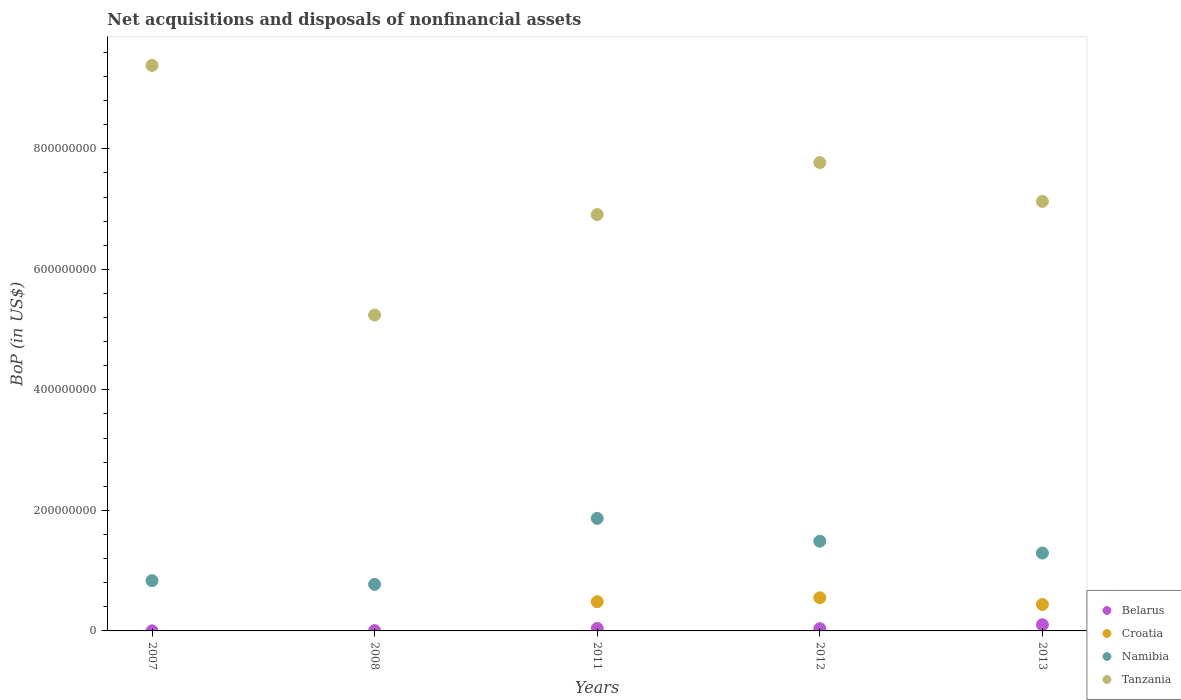How many different coloured dotlines are there?
Offer a very short reply. 4. Is the number of dotlines equal to the number of legend labels?
Offer a terse response. No. What is the Balance of Payments in Tanzania in 2007?
Ensure brevity in your answer.  9.39e+08. Across all years, what is the maximum Balance of Payments in Tanzania?
Offer a very short reply. 9.39e+08. What is the total Balance of Payments in Namibia in the graph?
Offer a terse response. 6.25e+08. What is the difference between the Balance of Payments in Croatia in 2011 and that in 2012?
Make the answer very short. -6.49e+06. What is the difference between the Balance of Payments in Namibia in 2013 and the Balance of Payments in Croatia in 2007?
Offer a terse response. 1.29e+08. What is the average Balance of Payments in Belarus per year?
Provide a short and direct response. 3.74e+06. In the year 2007, what is the difference between the Balance of Payments in Tanzania and Balance of Payments in Belarus?
Give a very brief answer. 9.38e+08. What is the ratio of the Balance of Payments in Belarus in 2008 to that in 2012?
Offer a terse response. 0.14. Is the Balance of Payments in Namibia in 2008 less than that in 2013?
Your response must be concise. Yes. What is the difference between the highest and the second highest Balance of Payments in Belarus?
Provide a short and direct response. 6.20e+06. What is the difference between the highest and the lowest Balance of Payments in Croatia?
Your answer should be very brief. 5.50e+07. In how many years, is the Balance of Payments in Namibia greater than the average Balance of Payments in Namibia taken over all years?
Your answer should be compact. 3. Is the Balance of Payments in Tanzania strictly greater than the Balance of Payments in Croatia over the years?
Make the answer very short. Yes. Is the Balance of Payments in Tanzania strictly less than the Balance of Payments in Namibia over the years?
Keep it short and to the point. No. How many years are there in the graph?
Provide a succinct answer. 5. What is the difference between two consecutive major ticks on the Y-axis?
Provide a succinct answer. 2.00e+08. Are the values on the major ticks of Y-axis written in scientific E-notation?
Provide a succinct answer. No. Does the graph contain any zero values?
Provide a succinct answer. Yes. Where does the legend appear in the graph?
Your answer should be compact. Bottom right. How many legend labels are there?
Give a very brief answer. 4. What is the title of the graph?
Ensure brevity in your answer.  Net acquisitions and disposals of nonfinancial assets. Does "San Marino" appear as one of the legend labels in the graph?
Your answer should be compact. No. What is the label or title of the X-axis?
Keep it short and to the point. Years. What is the label or title of the Y-axis?
Offer a very short reply. BoP (in US$). What is the BoP (in US$) in Belarus in 2007?
Provide a short and direct response. 1.00e+05. What is the BoP (in US$) of Namibia in 2007?
Give a very brief answer. 8.34e+07. What is the BoP (in US$) of Tanzania in 2007?
Offer a terse response. 9.39e+08. What is the BoP (in US$) of Croatia in 2008?
Provide a succinct answer. 0. What is the BoP (in US$) in Namibia in 2008?
Give a very brief answer. 7.72e+07. What is the BoP (in US$) in Tanzania in 2008?
Provide a succinct answer. 5.24e+08. What is the BoP (in US$) in Belarus in 2011?
Make the answer very short. 4.10e+06. What is the BoP (in US$) of Croatia in 2011?
Offer a very short reply. 4.85e+07. What is the BoP (in US$) of Namibia in 2011?
Offer a very short reply. 1.87e+08. What is the BoP (in US$) of Tanzania in 2011?
Your answer should be very brief. 6.91e+08. What is the BoP (in US$) in Belarus in 2012?
Make the answer very short. 3.70e+06. What is the BoP (in US$) in Croatia in 2012?
Provide a short and direct response. 5.50e+07. What is the BoP (in US$) of Namibia in 2012?
Offer a very short reply. 1.49e+08. What is the BoP (in US$) of Tanzania in 2012?
Give a very brief answer. 7.77e+08. What is the BoP (in US$) in Belarus in 2013?
Offer a very short reply. 1.03e+07. What is the BoP (in US$) of Croatia in 2013?
Offer a terse response. 4.39e+07. What is the BoP (in US$) in Namibia in 2013?
Ensure brevity in your answer.  1.29e+08. What is the BoP (in US$) in Tanzania in 2013?
Make the answer very short. 7.13e+08. Across all years, what is the maximum BoP (in US$) of Belarus?
Offer a very short reply. 1.03e+07. Across all years, what is the maximum BoP (in US$) in Croatia?
Offer a very short reply. 5.50e+07. Across all years, what is the maximum BoP (in US$) in Namibia?
Your answer should be compact. 1.87e+08. Across all years, what is the maximum BoP (in US$) in Tanzania?
Give a very brief answer. 9.39e+08. Across all years, what is the minimum BoP (in US$) of Namibia?
Keep it short and to the point. 7.72e+07. Across all years, what is the minimum BoP (in US$) in Tanzania?
Provide a short and direct response. 5.24e+08. What is the total BoP (in US$) of Belarus in the graph?
Your response must be concise. 1.87e+07. What is the total BoP (in US$) in Croatia in the graph?
Provide a short and direct response. 1.47e+08. What is the total BoP (in US$) in Namibia in the graph?
Your answer should be very brief. 6.25e+08. What is the total BoP (in US$) in Tanzania in the graph?
Give a very brief answer. 3.64e+09. What is the difference between the BoP (in US$) of Belarus in 2007 and that in 2008?
Make the answer very short. -4.00e+05. What is the difference between the BoP (in US$) in Namibia in 2007 and that in 2008?
Provide a succinct answer. 6.20e+06. What is the difference between the BoP (in US$) of Tanzania in 2007 and that in 2008?
Give a very brief answer. 4.14e+08. What is the difference between the BoP (in US$) in Namibia in 2007 and that in 2011?
Give a very brief answer. -1.03e+08. What is the difference between the BoP (in US$) of Tanzania in 2007 and that in 2011?
Provide a succinct answer. 2.48e+08. What is the difference between the BoP (in US$) in Belarus in 2007 and that in 2012?
Keep it short and to the point. -3.60e+06. What is the difference between the BoP (in US$) of Namibia in 2007 and that in 2012?
Ensure brevity in your answer.  -6.54e+07. What is the difference between the BoP (in US$) of Tanzania in 2007 and that in 2012?
Your answer should be compact. 1.61e+08. What is the difference between the BoP (in US$) of Belarus in 2007 and that in 2013?
Provide a succinct answer. -1.02e+07. What is the difference between the BoP (in US$) of Namibia in 2007 and that in 2013?
Your response must be concise. -4.58e+07. What is the difference between the BoP (in US$) of Tanzania in 2007 and that in 2013?
Your response must be concise. 2.26e+08. What is the difference between the BoP (in US$) of Belarus in 2008 and that in 2011?
Make the answer very short. -3.60e+06. What is the difference between the BoP (in US$) of Namibia in 2008 and that in 2011?
Keep it short and to the point. -1.10e+08. What is the difference between the BoP (in US$) in Tanzania in 2008 and that in 2011?
Provide a short and direct response. -1.67e+08. What is the difference between the BoP (in US$) of Belarus in 2008 and that in 2012?
Give a very brief answer. -3.20e+06. What is the difference between the BoP (in US$) of Namibia in 2008 and that in 2012?
Ensure brevity in your answer.  -7.16e+07. What is the difference between the BoP (in US$) in Tanzania in 2008 and that in 2012?
Your answer should be very brief. -2.53e+08. What is the difference between the BoP (in US$) in Belarus in 2008 and that in 2013?
Provide a short and direct response. -9.80e+06. What is the difference between the BoP (in US$) in Namibia in 2008 and that in 2013?
Offer a terse response. -5.20e+07. What is the difference between the BoP (in US$) in Tanzania in 2008 and that in 2013?
Offer a very short reply. -1.89e+08. What is the difference between the BoP (in US$) in Croatia in 2011 and that in 2012?
Your answer should be very brief. -6.49e+06. What is the difference between the BoP (in US$) of Namibia in 2011 and that in 2012?
Your answer should be compact. 3.79e+07. What is the difference between the BoP (in US$) of Tanzania in 2011 and that in 2012?
Your response must be concise. -8.63e+07. What is the difference between the BoP (in US$) of Belarus in 2011 and that in 2013?
Offer a terse response. -6.20e+06. What is the difference between the BoP (in US$) of Croatia in 2011 and that in 2013?
Your answer should be very brief. 4.67e+06. What is the difference between the BoP (in US$) in Namibia in 2011 and that in 2013?
Your response must be concise. 5.76e+07. What is the difference between the BoP (in US$) of Tanzania in 2011 and that in 2013?
Your answer should be compact. -2.19e+07. What is the difference between the BoP (in US$) in Belarus in 2012 and that in 2013?
Provide a succinct answer. -6.60e+06. What is the difference between the BoP (in US$) in Croatia in 2012 and that in 2013?
Keep it short and to the point. 1.12e+07. What is the difference between the BoP (in US$) of Namibia in 2012 and that in 2013?
Your response must be concise. 1.96e+07. What is the difference between the BoP (in US$) in Tanzania in 2012 and that in 2013?
Your response must be concise. 6.44e+07. What is the difference between the BoP (in US$) in Belarus in 2007 and the BoP (in US$) in Namibia in 2008?
Your response must be concise. -7.71e+07. What is the difference between the BoP (in US$) in Belarus in 2007 and the BoP (in US$) in Tanzania in 2008?
Your answer should be compact. -5.24e+08. What is the difference between the BoP (in US$) of Namibia in 2007 and the BoP (in US$) of Tanzania in 2008?
Offer a terse response. -4.41e+08. What is the difference between the BoP (in US$) in Belarus in 2007 and the BoP (in US$) in Croatia in 2011?
Keep it short and to the point. -4.84e+07. What is the difference between the BoP (in US$) of Belarus in 2007 and the BoP (in US$) of Namibia in 2011?
Ensure brevity in your answer.  -1.87e+08. What is the difference between the BoP (in US$) of Belarus in 2007 and the BoP (in US$) of Tanzania in 2011?
Your answer should be compact. -6.91e+08. What is the difference between the BoP (in US$) in Namibia in 2007 and the BoP (in US$) in Tanzania in 2011?
Make the answer very short. -6.08e+08. What is the difference between the BoP (in US$) of Belarus in 2007 and the BoP (in US$) of Croatia in 2012?
Ensure brevity in your answer.  -5.49e+07. What is the difference between the BoP (in US$) in Belarus in 2007 and the BoP (in US$) in Namibia in 2012?
Ensure brevity in your answer.  -1.49e+08. What is the difference between the BoP (in US$) of Belarus in 2007 and the BoP (in US$) of Tanzania in 2012?
Your answer should be very brief. -7.77e+08. What is the difference between the BoP (in US$) of Namibia in 2007 and the BoP (in US$) of Tanzania in 2012?
Provide a short and direct response. -6.94e+08. What is the difference between the BoP (in US$) in Belarus in 2007 and the BoP (in US$) in Croatia in 2013?
Your answer should be compact. -4.38e+07. What is the difference between the BoP (in US$) in Belarus in 2007 and the BoP (in US$) in Namibia in 2013?
Make the answer very short. -1.29e+08. What is the difference between the BoP (in US$) in Belarus in 2007 and the BoP (in US$) in Tanzania in 2013?
Your response must be concise. -7.13e+08. What is the difference between the BoP (in US$) of Namibia in 2007 and the BoP (in US$) of Tanzania in 2013?
Provide a short and direct response. -6.29e+08. What is the difference between the BoP (in US$) of Belarus in 2008 and the BoP (in US$) of Croatia in 2011?
Provide a short and direct response. -4.80e+07. What is the difference between the BoP (in US$) in Belarus in 2008 and the BoP (in US$) in Namibia in 2011?
Give a very brief answer. -1.86e+08. What is the difference between the BoP (in US$) in Belarus in 2008 and the BoP (in US$) in Tanzania in 2011?
Your response must be concise. -6.90e+08. What is the difference between the BoP (in US$) in Namibia in 2008 and the BoP (in US$) in Tanzania in 2011?
Offer a terse response. -6.14e+08. What is the difference between the BoP (in US$) of Belarus in 2008 and the BoP (in US$) of Croatia in 2012?
Give a very brief answer. -5.45e+07. What is the difference between the BoP (in US$) of Belarus in 2008 and the BoP (in US$) of Namibia in 2012?
Your answer should be compact. -1.48e+08. What is the difference between the BoP (in US$) of Belarus in 2008 and the BoP (in US$) of Tanzania in 2012?
Give a very brief answer. -7.77e+08. What is the difference between the BoP (in US$) in Namibia in 2008 and the BoP (in US$) in Tanzania in 2012?
Offer a terse response. -7.00e+08. What is the difference between the BoP (in US$) in Belarus in 2008 and the BoP (in US$) in Croatia in 2013?
Give a very brief answer. -4.34e+07. What is the difference between the BoP (in US$) in Belarus in 2008 and the BoP (in US$) in Namibia in 2013?
Give a very brief answer. -1.29e+08. What is the difference between the BoP (in US$) of Belarus in 2008 and the BoP (in US$) of Tanzania in 2013?
Your answer should be very brief. -7.12e+08. What is the difference between the BoP (in US$) in Namibia in 2008 and the BoP (in US$) in Tanzania in 2013?
Offer a terse response. -6.36e+08. What is the difference between the BoP (in US$) of Belarus in 2011 and the BoP (in US$) of Croatia in 2012?
Your response must be concise. -5.09e+07. What is the difference between the BoP (in US$) of Belarus in 2011 and the BoP (in US$) of Namibia in 2012?
Your answer should be compact. -1.45e+08. What is the difference between the BoP (in US$) of Belarus in 2011 and the BoP (in US$) of Tanzania in 2012?
Make the answer very short. -7.73e+08. What is the difference between the BoP (in US$) in Croatia in 2011 and the BoP (in US$) in Namibia in 2012?
Offer a terse response. -1.00e+08. What is the difference between the BoP (in US$) of Croatia in 2011 and the BoP (in US$) of Tanzania in 2012?
Provide a short and direct response. -7.29e+08. What is the difference between the BoP (in US$) in Namibia in 2011 and the BoP (in US$) in Tanzania in 2012?
Offer a very short reply. -5.90e+08. What is the difference between the BoP (in US$) of Belarus in 2011 and the BoP (in US$) of Croatia in 2013?
Keep it short and to the point. -3.98e+07. What is the difference between the BoP (in US$) in Belarus in 2011 and the BoP (in US$) in Namibia in 2013?
Keep it short and to the point. -1.25e+08. What is the difference between the BoP (in US$) of Belarus in 2011 and the BoP (in US$) of Tanzania in 2013?
Keep it short and to the point. -7.09e+08. What is the difference between the BoP (in US$) of Croatia in 2011 and the BoP (in US$) of Namibia in 2013?
Ensure brevity in your answer.  -8.07e+07. What is the difference between the BoP (in US$) of Croatia in 2011 and the BoP (in US$) of Tanzania in 2013?
Offer a terse response. -6.64e+08. What is the difference between the BoP (in US$) of Namibia in 2011 and the BoP (in US$) of Tanzania in 2013?
Offer a terse response. -5.26e+08. What is the difference between the BoP (in US$) in Belarus in 2012 and the BoP (in US$) in Croatia in 2013?
Your answer should be compact. -4.02e+07. What is the difference between the BoP (in US$) in Belarus in 2012 and the BoP (in US$) in Namibia in 2013?
Provide a succinct answer. -1.26e+08. What is the difference between the BoP (in US$) of Belarus in 2012 and the BoP (in US$) of Tanzania in 2013?
Provide a short and direct response. -7.09e+08. What is the difference between the BoP (in US$) in Croatia in 2012 and the BoP (in US$) in Namibia in 2013?
Keep it short and to the point. -7.42e+07. What is the difference between the BoP (in US$) in Croatia in 2012 and the BoP (in US$) in Tanzania in 2013?
Provide a succinct answer. -6.58e+08. What is the difference between the BoP (in US$) of Namibia in 2012 and the BoP (in US$) of Tanzania in 2013?
Offer a terse response. -5.64e+08. What is the average BoP (in US$) in Belarus per year?
Offer a terse response. 3.74e+06. What is the average BoP (in US$) in Croatia per year?
Your answer should be very brief. 2.95e+07. What is the average BoP (in US$) of Namibia per year?
Your answer should be very brief. 1.25e+08. What is the average BoP (in US$) in Tanzania per year?
Offer a very short reply. 7.29e+08. In the year 2007, what is the difference between the BoP (in US$) in Belarus and BoP (in US$) in Namibia?
Make the answer very short. -8.33e+07. In the year 2007, what is the difference between the BoP (in US$) in Belarus and BoP (in US$) in Tanzania?
Ensure brevity in your answer.  -9.38e+08. In the year 2007, what is the difference between the BoP (in US$) of Namibia and BoP (in US$) of Tanzania?
Provide a succinct answer. -8.55e+08. In the year 2008, what is the difference between the BoP (in US$) of Belarus and BoP (in US$) of Namibia?
Offer a terse response. -7.67e+07. In the year 2008, what is the difference between the BoP (in US$) in Belarus and BoP (in US$) in Tanzania?
Your answer should be very brief. -5.24e+08. In the year 2008, what is the difference between the BoP (in US$) of Namibia and BoP (in US$) of Tanzania?
Ensure brevity in your answer.  -4.47e+08. In the year 2011, what is the difference between the BoP (in US$) in Belarus and BoP (in US$) in Croatia?
Keep it short and to the point. -4.44e+07. In the year 2011, what is the difference between the BoP (in US$) of Belarus and BoP (in US$) of Namibia?
Provide a short and direct response. -1.83e+08. In the year 2011, what is the difference between the BoP (in US$) in Belarus and BoP (in US$) in Tanzania?
Your answer should be compact. -6.87e+08. In the year 2011, what is the difference between the BoP (in US$) of Croatia and BoP (in US$) of Namibia?
Give a very brief answer. -1.38e+08. In the year 2011, what is the difference between the BoP (in US$) of Croatia and BoP (in US$) of Tanzania?
Keep it short and to the point. -6.42e+08. In the year 2011, what is the difference between the BoP (in US$) in Namibia and BoP (in US$) in Tanzania?
Make the answer very short. -5.04e+08. In the year 2012, what is the difference between the BoP (in US$) of Belarus and BoP (in US$) of Croatia?
Your answer should be very brief. -5.13e+07. In the year 2012, what is the difference between the BoP (in US$) of Belarus and BoP (in US$) of Namibia?
Offer a terse response. -1.45e+08. In the year 2012, what is the difference between the BoP (in US$) of Belarus and BoP (in US$) of Tanzania?
Offer a very short reply. -7.74e+08. In the year 2012, what is the difference between the BoP (in US$) in Croatia and BoP (in US$) in Namibia?
Keep it short and to the point. -9.38e+07. In the year 2012, what is the difference between the BoP (in US$) in Croatia and BoP (in US$) in Tanzania?
Offer a terse response. -7.22e+08. In the year 2012, what is the difference between the BoP (in US$) in Namibia and BoP (in US$) in Tanzania?
Keep it short and to the point. -6.28e+08. In the year 2013, what is the difference between the BoP (in US$) of Belarus and BoP (in US$) of Croatia?
Provide a short and direct response. -3.36e+07. In the year 2013, what is the difference between the BoP (in US$) of Belarus and BoP (in US$) of Namibia?
Ensure brevity in your answer.  -1.19e+08. In the year 2013, what is the difference between the BoP (in US$) of Belarus and BoP (in US$) of Tanzania?
Keep it short and to the point. -7.02e+08. In the year 2013, what is the difference between the BoP (in US$) in Croatia and BoP (in US$) in Namibia?
Offer a terse response. -8.54e+07. In the year 2013, what is the difference between the BoP (in US$) of Croatia and BoP (in US$) of Tanzania?
Offer a very short reply. -6.69e+08. In the year 2013, what is the difference between the BoP (in US$) of Namibia and BoP (in US$) of Tanzania?
Your response must be concise. -5.84e+08. What is the ratio of the BoP (in US$) of Namibia in 2007 to that in 2008?
Keep it short and to the point. 1.08. What is the ratio of the BoP (in US$) of Tanzania in 2007 to that in 2008?
Make the answer very short. 1.79. What is the ratio of the BoP (in US$) of Belarus in 2007 to that in 2011?
Your answer should be very brief. 0.02. What is the ratio of the BoP (in US$) in Namibia in 2007 to that in 2011?
Offer a very short reply. 0.45. What is the ratio of the BoP (in US$) of Tanzania in 2007 to that in 2011?
Provide a succinct answer. 1.36. What is the ratio of the BoP (in US$) in Belarus in 2007 to that in 2012?
Offer a very short reply. 0.03. What is the ratio of the BoP (in US$) of Namibia in 2007 to that in 2012?
Make the answer very short. 0.56. What is the ratio of the BoP (in US$) of Tanzania in 2007 to that in 2012?
Your response must be concise. 1.21. What is the ratio of the BoP (in US$) of Belarus in 2007 to that in 2013?
Provide a succinct answer. 0.01. What is the ratio of the BoP (in US$) in Namibia in 2007 to that in 2013?
Make the answer very short. 0.65. What is the ratio of the BoP (in US$) in Tanzania in 2007 to that in 2013?
Offer a very short reply. 1.32. What is the ratio of the BoP (in US$) of Belarus in 2008 to that in 2011?
Your answer should be compact. 0.12. What is the ratio of the BoP (in US$) in Namibia in 2008 to that in 2011?
Your response must be concise. 0.41. What is the ratio of the BoP (in US$) of Tanzania in 2008 to that in 2011?
Your answer should be compact. 0.76. What is the ratio of the BoP (in US$) in Belarus in 2008 to that in 2012?
Ensure brevity in your answer.  0.14. What is the ratio of the BoP (in US$) in Namibia in 2008 to that in 2012?
Provide a succinct answer. 0.52. What is the ratio of the BoP (in US$) in Tanzania in 2008 to that in 2012?
Offer a terse response. 0.67. What is the ratio of the BoP (in US$) in Belarus in 2008 to that in 2013?
Provide a short and direct response. 0.05. What is the ratio of the BoP (in US$) of Namibia in 2008 to that in 2013?
Provide a succinct answer. 0.6. What is the ratio of the BoP (in US$) in Tanzania in 2008 to that in 2013?
Ensure brevity in your answer.  0.74. What is the ratio of the BoP (in US$) of Belarus in 2011 to that in 2012?
Give a very brief answer. 1.11. What is the ratio of the BoP (in US$) in Croatia in 2011 to that in 2012?
Offer a very short reply. 0.88. What is the ratio of the BoP (in US$) of Namibia in 2011 to that in 2012?
Your answer should be compact. 1.25. What is the ratio of the BoP (in US$) of Tanzania in 2011 to that in 2012?
Your response must be concise. 0.89. What is the ratio of the BoP (in US$) in Belarus in 2011 to that in 2013?
Make the answer very short. 0.4. What is the ratio of the BoP (in US$) in Croatia in 2011 to that in 2013?
Offer a very short reply. 1.11. What is the ratio of the BoP (in US$) in Namibia in 2011 to that in 2013?
Your response must be concise. 1.45. What is the ratio of the BoP (in US$) of Tanzania in 2011 to that in 2013?
Your response must be concise. 0.97. What is the ratio of the BoP (in US$) of Belarus in 2012 to that in 2013?
Your answer should be very brief. 0.36. What is the ratio of the BoP (in US$) of Croatia in 2012 to that in 2013?
Make the answer very short. 1.25. What is the ratio of the BoP (in US$) in Namibia in 2012 to that in 2013?
Keep it short and to the point. 1.15. What is the ratio of the BoP (in US$) in Tanzania in 2012 to that in 2013?
Give a very brief answer. 1.09. What is the difference between the highest and the second highest BoP (in US$) of Belarus?
Provide a short and direct response. 6.20e+06. What is the difference between the highest and the second highest BoP (in US$) in Croatia?
Offer a terse response. 6.49e+06. What is the difference between the highest and the second highest BoP (in US$) of Namibia?
Your response must be concise. 3.79e+07. What is the difference between the highest and the second highest BoP (in US$) in Tanzania?
Your answer should be compact. 1.61e+08. What is the difference between the highest and the lowest BoP (in US$) in Belarus?
Give a very brief answer. 1.02e+07. What is the difference between the highest and the lowest BoP (in US$) of Croatia?
Your response must be concise. 5.50e+07. What is the difference between the highest and the lowest BoP (in US$) of Namibia?
Provide a short and direct response. 1.10e+08. What is the difference between the highest and the lowest BoP (in US$) in Tanzania?
Your answer should be compact. 4.14e+08. 